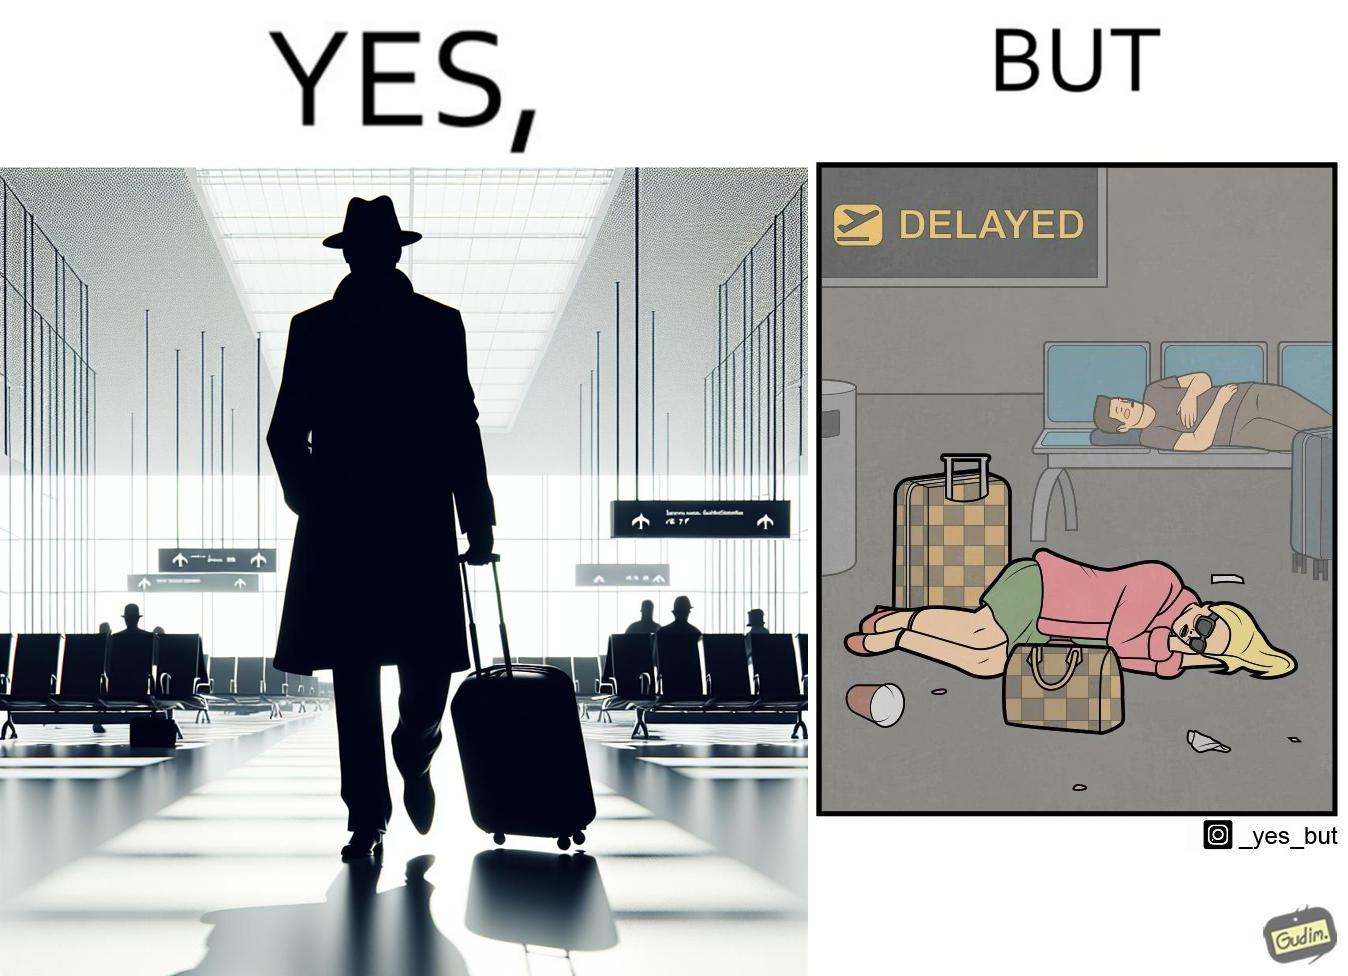What makes this image funny or satirical? The image is ironical, as an apparently rich person walks inside the airport with luggage, but has to sleep on the floor  due to the flight being delayed and an absence of vacant seats in the airport. 